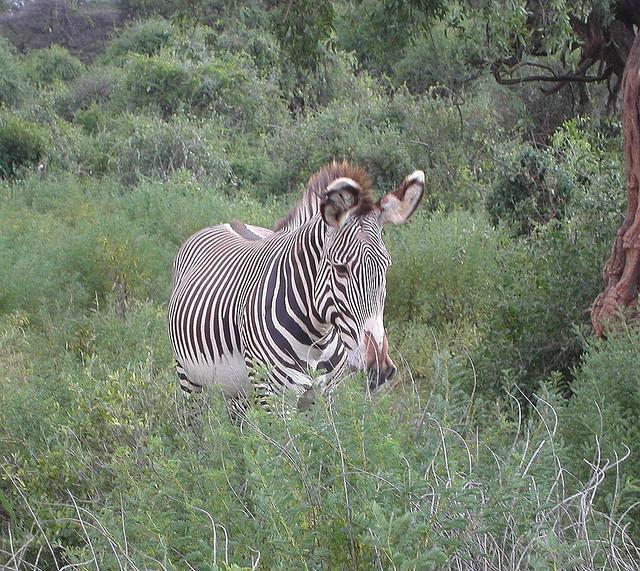How many people are in the photo?
Give a very brief answer. 0. 